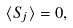Convert formula to latex. <formula><loc_0><loc_0><loc_500><loc_500>\langle { S } _ { j } \rangle = 0 ,</formula> 